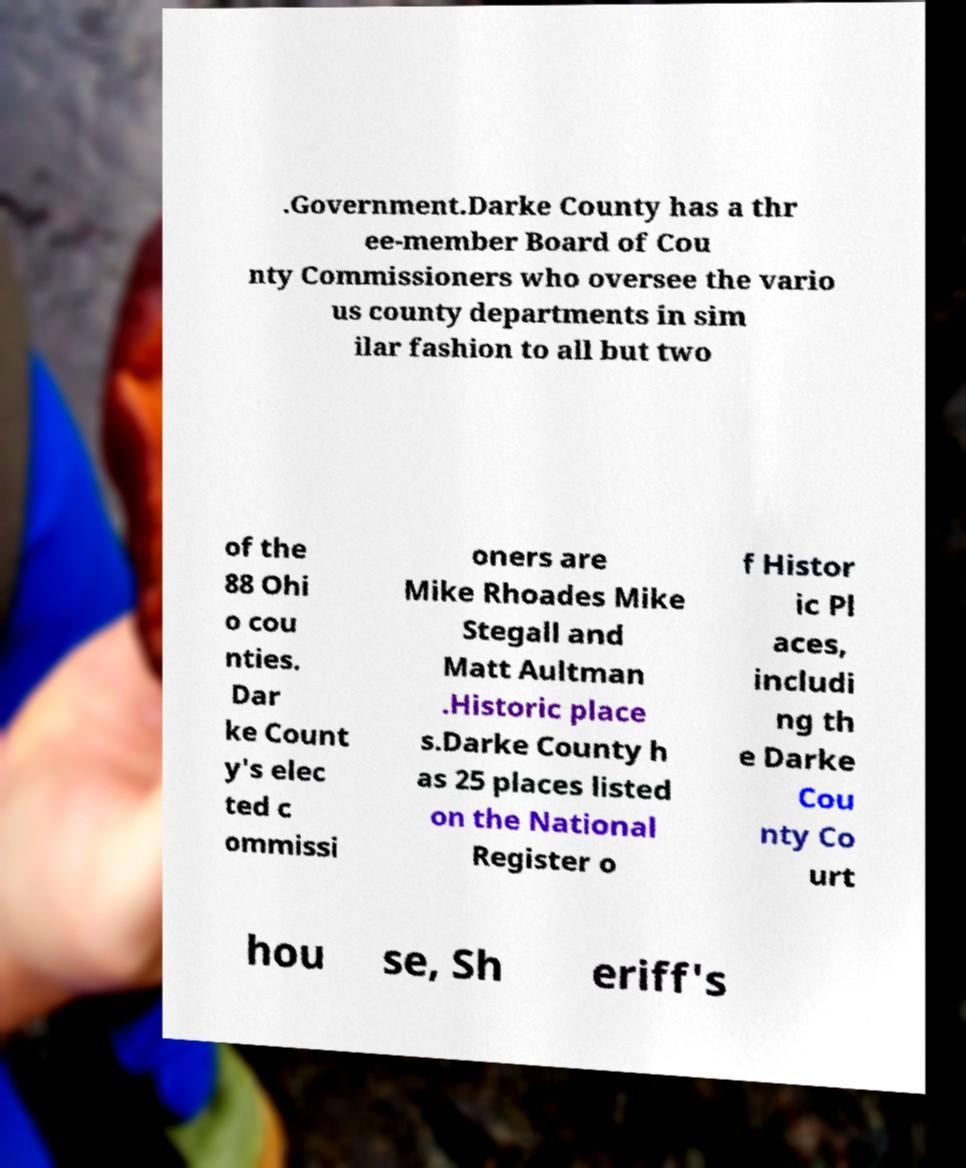There's text embedded in this image that I need extracted. Can you transcribe it verbatim? .Government.Darke County has a thr ee-member Board of Cou nty Commissioners who oversee the vario us county departments in sim ilar fashion to all but two of the 88 Ohi o cou nties. Dar ke Count y's elec ted c ommissi oners are Mike Rhoades Mike Stegall and Matt Aultman .Historic place s.Darke County h as 25 places listed on the National Register o f Histor ic Pl aces, includi ng th e Darke Cou nty Co urt hou se, Sh eriff's 